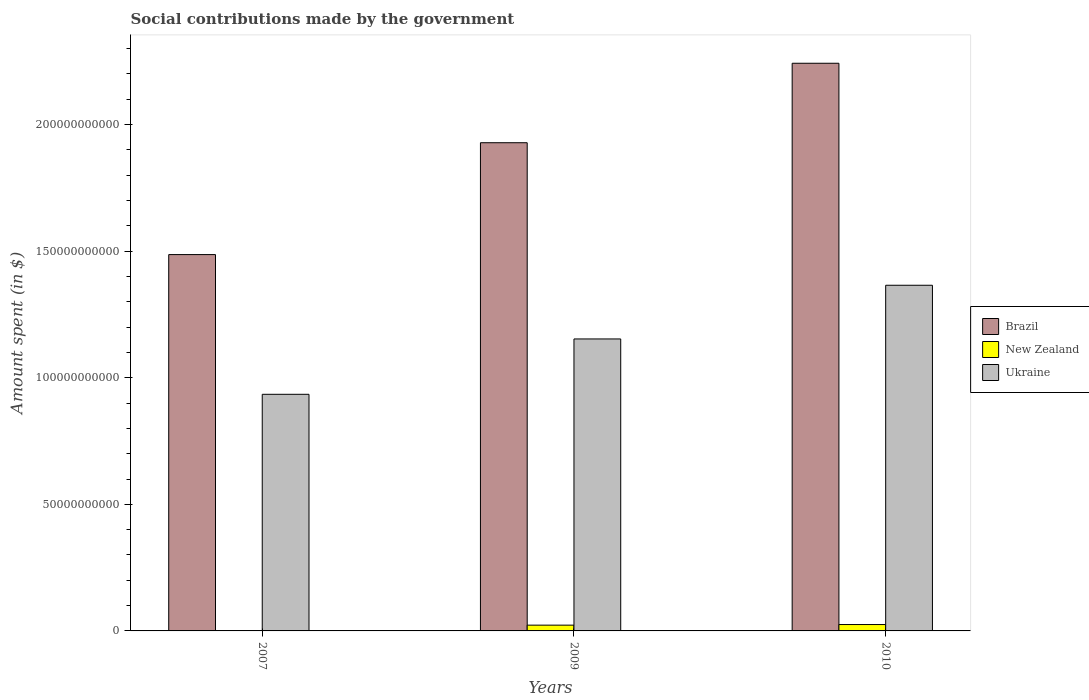Are the number of bars on each tick of the X-axis equal?
Ensure brevity in your answer.  Yes. How many bars are there on the 1st tick from the left?
Keep it short and to the point. 3. In how many cases, is the number of bars for a given year not equal to the number of legend labels?
Make the answer very short. 0. What is the amount spent on social contributions in New Zealand in 2010?
Your response must be concise. 2.52e+09. Across all years, what is the maximum amount spent on social contributions in Brazil?
Ensure brevity in your answer.  2.24e+11. Across all years, what is the minimum amount spent on social contributions in New Zealand?
Provide a succinct answer. 1.01e+08. In which year was the amount spent on social contributions in Ukraine maximum?
Make the answer very short. 2010. What is the total amount spent on social contributions in New Zealand in the graph?
Your answer should be very brief. 4.90e+09. What is the difference between the amount spent on social contributions in New Zealand in 2007 and that in 2010?
Your answer should be very brief. -2.42e+09. What is the difference between the amount spent on social contributions in New Zealand in 2007 and the amount spent on social contributions in Ukraine in 2010?
Provide a short and direct response. -1.36e+11. What is the average amount spent on social contributions in Brazil per year?
Your answer should be compact. 1.89e+11. In the year 2007, what is the difference between the amount spent on social contributions in New Zealand and amount spent on social contributions in Brazil?
Your answer should be very brief. -1.49e+11. What is the ratio of the amount spent on social contributions in Ukraine in 2007 to that in 2010?
Offer a very short reply. 0.68. Is the difference between the amount spent on social contributions in New Zealand in 2009 and 2010 greater than the difference between the amount spent on social contributions in Brazil in 2009 and 2010?
Ensure brevity in your answer.  Yes. What is the difference between the highest and the second highest amount spent on social contributions in Brazil?
Ensure brevity in your answer.  3.14e+1. What is the difference between the highest and the lowest amount spent on social contributions in Brazil?
Make the answer very short. 7.56e+1. Is the sum of the amount spent on social contributions in Ukraine in 2007 and 2009 greater than the maximum amount spent on social contributions in New Zealand across all years?
Ensure brevity in your answer.  Yes. What does the 1st bar from the left in 2007 represents?
Your answer should be very brief. Brazil. What does the 1st bar from the right in 2010 represents?
Your response must be concise. Ukraine. What is the difference between two consecutive major ticks on the Y-axis?
Ensure brevity in your answer.  5.00e+1. Where does the legend appear in the graph?
Your answer should be very brief. Center right. What is the title of the graph?
Ensure brevity in your answer.  Social contributions made by the government. What is the label or title of the X-axis?
Your answer should be compact. Years. What is the label or title of the Y-axis?
Your response must be concise. Amount spent (in $). What is the Amount spent (in $) of Brazil in 2007?
Give a very brief answer. 1.49e+11. What is the Amount spent (in $) in New Zealand in 2007?
Provide a succinct answer. 1.01e+08. What is the Amount spent (in $) of Ukraine in 2007?
Provide a succinct answer. 9.35e+1. What is the Amount spent (in $) in Brazil in 2009?
Offer a terse response. 1.93e+11. What is the Amount spent (in $) in New Zealand in 2009?
Offer a very short reply. 2.28e+09. What is the Amount spent (in $) in Ukraine in 2009?
Offer a terse response. 1.15e+11. What is the Amount spent (in $) of Brazil in 2010?
Ensure brevity in your answer.  2.24e+11. What is the Amount spent (in $) in New Zealand in 2010?
Provide a short and direct response. 2.52e+09. What is the Amount spent (in $) of Ukraine in 2010?
Provide a succinct answer. 1.37e+11. Across all years, what is the maximum Amount spent (in $) of Brazil?
Provide a succinct answer. 2.24e+11. Across all years, what is the maximum Amount spent (in $) of New Zealand?
Keep it short and to the point. 2.52e+09. Across all years, what is the maximum Amount spent (in $) of Ukraine?
Offer a terse response. 1.37e+11. Across all years, what is the minimum Amount spent (in $) of Brazil?
Your answer should be very brief. 1.49e+11. Across all years, what is the minimum Amount spent (in $) of New Zealand?
Keep it short and to the point. 1.01e+08. Across all years, what is the minimum Amount spent (in $) of Ukraine?
Ensure brevity in your answer.  9.35e+1. What is the total Amount spent (in $) of Brazil in the graph?
Provide a short and direct response. 5.66e+11. What is the total Amount spent (in $) in New Zealand in the graph?
Provide a short and direct response. 4.90e+09. What is the total Amount spent (in $) of Ukraine in the graph?
Provide a short and direct response. 3.45e+11. What is the difference between the Amount spent (in $) of Brazil in 2007 and that in 2009?
Your answer should be compact. -4.42e+1. What is the difference between the Amount spent (in $) in New Zealand in 2007 and that in 2009?
Give a very brief answer. -2.18e+09. What is the difference between the Amount spent (in $) of Ukraine in 2007 and that in 2009?
Your answer should be compact. -2.19e+1. What is the difference between the Amount spent (in $) of Brazil in 2007 and that in 2010?
Ensure brevity in your answer.  -7.56e+1. What is the difference between the Amount spent (in $) in New Zealand in 2007 and that in 2010?
Your answer should be very brief. -2.42e+09. What is the difference between the Amount spent (in $) in Ukraine in 2007 and that in 2010?
Ensure brevity in your answer.  -4.31e+1. What is the difference between the Amount spent (in $) in Brazil in 2009 and that in 2010?
Give a very brief answer. -3.14e+1. What is the difference between the Amount spent (in $) of New Zealand in 2009 and that in 2010?
Provide a short and direct response. -2.44e+08. What is the difference between the Amount spent (in $) in Ukraine in 2009 and that in 2010?
Your answer should be very brief. -2.12e+1. What is the difference between the Amount spent (in $) of Brazil in 2007 and the Amount spent (in $) of New Zealand in 2009?
Your response must be concise. 1.46e+11. What is the difference between the Amount spent (in $) of Brazil in 2007 and the Amount spent (in $) of Ukraine in 2009?
Ensure brevity in your answer.  3.33e+1. What is the difference between the Amount spent (in $) in New Zealand in 2007 and the Amount spent (in $) in Ukraine in 2009?
Make the answer very short. -1.15e+11. What is the difference between the Amount spent (in $) in Brazil in 2007 and the Amount spent (in $) in New Zealand in 2010?
Offer a very short reply. 1.46e+11. What is the difference between the Amount spent (in $) in Brazil in 2007 and the Amount spent (in $) in Ukraine in 2010?
Your answer should be compact. 1.21e+1. What is the difference between the Amount spent (in $) of New Zealand in 2007 and the Amount spent (in $) of Ukraine in 2010?
Ensure brevity in your answer.  -1.36e+11. What is the difference between the Amount spent (in $) of Brazil in 2009 and the Amount spent (in $) of New Zealand in 2010?
Offer a terse response. 1.90e+11. What is the difference between the Amount spent (in $) of Brazil in 2009 and the Amount spent (in $) of Ukraine in 2010?
Provide a short and direct response. 5.63e+1. What is the difference between the Amount spent (in $) in New Zealand in 2009 and the Amount spent (in $) in Ukraine in 2010?
Your answer should be compact. -1.34e+11. What is the average Amount spent (in $) in Brazil per year?
Provide a succinct answer. 1.89e+11. What is the average Amount spent (in $) in New Zealand per year?
Offer a terse response. 1.63e+09. What is the average Amount spent (in $) of Ukraine per year?
Offer a very short reply. 1.15e+11. In the year 2007, what is the difference between the Amount spent (in $) in Brazil and Amount spent (in $) in New Zealand?
Your answer should be compact. 1.49e+11. In the year 2007, what is the difference between the Amount spent (in $) of Brazil and Amount spent (in $) of Ukraine?
Provide a succinct answer. 5.52e+1. In the year 2007, what is the difference between the Amount spent (in $) in New Zealand and Amount spent (in $) in Ukraine?
Keep it short and to the point. -9.34e+1. In the year 2009, what is the difference between the Amount spent (in $) in Brazil and Amount spent (in $) in New Zealand?
Your response must be concise. 1.91e+11. In the year 2009, what is the difference between the Amount spent (in $) of Brazil and Amount spent (in $) of Ukraine?
Your answer should be very brief. 7.75e+1. In the year 2009, what is the difference between the Amount spent (in $) of New Zealand and Amount spent (in $) of Ukraine?
Keep it short and to the point. -1.13e+11. In the year 2010, what is the difference between the Amount spent (in $) in Brazil and Amount spent (in $) in New Zealand?
Give a very brief answer. 2.22e+11. In the year 2010, what is the difference between the Amount spent (in $) in Brazil and Amount spent (in $) in Ukraine?
Provide a succinct answer. 8.77e+1. In the year 2010, what is the difference between the Amount spent (in $) of New Zealand and Amount spent (in $) of Ukraine?
Make the answer very short. -1.34e+11. What is the ratio of the Amount spent (in $) of Brazil in 2007 to that in 2009?
Make the answer very short. 0.77. What is the ratio of the Amount spent (in $) in New Zealand in 2007 to that in 2009?
Make the answer very short. 0.04. What is the ratio of the Amount spent (in $) of Ukraine in 2007 to that in 2009?
Your answer should be very brief. 0.81. What is the ratio of the Amount spent (in $) of Brazil in 2007 to that in 2010?
Offer a very short reply. 0.66. What is the ratio of the Amount spent (in $) in New Zealand in 2007 to that in 2010?
Your answer should be very brief. 0.04. What is the ratio of the Amount spent (in $) of Ukraine in 2007 to that in 2010?
Your response must be concise. 0.68. What is the ratio of the Amount spent (in $) of Brazil in 2009 to that in 2010?
Your response must be concise. 0.86. What is the ratio of the Amount spent (in $) in New Zealand in 2009 to that in 2010?
Give a very brief answer. 0.9. What is the ratio of the Amount spent (in $) in Ukraine in 2009 to that in 2010?
Keep it short and to the point. 0.84. What is the difference between the highest and the second highest Amount spent (in $) of Brazil?
Keep it short and to the point. 3.14e+1. What is the difference between the highest and the second highest Amount spent (in $) in New Zealand?
Provide a succinct answer. 2.44e+08. What is the difference between the highest and the second highest Amount spent (in $) in Ukraine?
Give a very brief answer. 2.12e+1. What is the difference between the highest and the lowest Amount spent (in $) of Brazil?
Offer a terse response. 7.56e+1. What is the difference between the highest and the lowest Amount spent (in $) of New Zealand?
Offer a very short reply. 2.42e+09. What is the difference between the highest and the lowest Amount spent (in $) in Ukraine?
Give a very brief answer. 4.31e+1. 